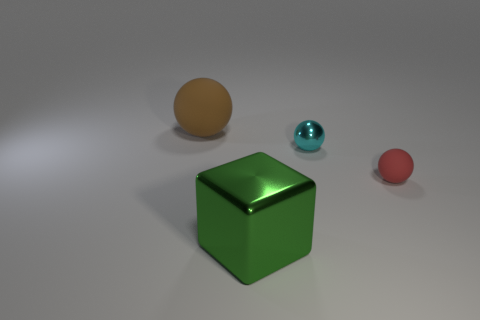Are any tiny metal spheres visible?
Your answer should be compact. Yes. Does the tiny matte thing have the same color as the tiny thing left of the small matte ball?
Provide a short and direct response. No. What is the color of the large rubber ball?
Your answer should be compact. Brown. Are there any other things that are the same shape as the small rubber object?
Offer a very short reply. Yes. What color is the other rubber object that is the same shape as the brown object?
Offer a terse response. Red. Do the cyan metallic thing and the small red object have the same shape?
Keep it short and to the point. Yes. How many cubes are cyan objects or green things?
Make the answer very short. 1. There is another object that is made of the same material as the brown thing; what color is it?
Ensure brevity in your answer.  Red. There is a rubber object on the right side of the cyan shiny object; is it the same size as the cyan metal sphere?
Provide a succinct answer. Yes. Is the material of the cube the same as the big thing left of the large shiny block?
Your answer should be very brief. No. 